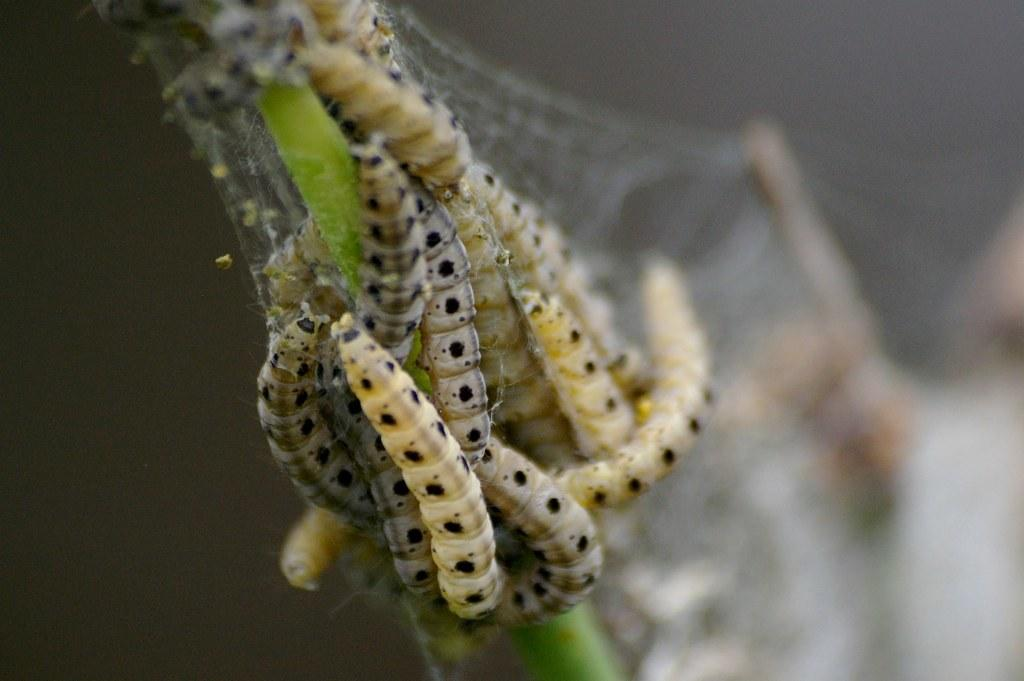What type of creatures are present in the image? There is a group of insects in the image. Where are the insects located? The insects are on a stem. Can you describe the background of the image? The background of the image is blurry. What type of pies can be seen in the image? There are no pies present in the image; it features a group of insects on a stem with a blurry background. 